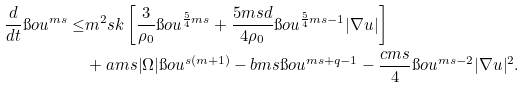<formula> <loc_0><loc_0><loc_500><loc_500>\frac { d } { d t } \i o u ^ { m s } \leq & m ^ { 2 } s k \left [ \frac { 3 } { \rho _ { 0 } } \i o u ^ { \frac { 5 } { 4 } m s } + \frac { 5 m s d } { 4 \rho _ { 0 } } \i o u ^ { \frac { 5 } { 4 } m s - 1 } | \nabla u | \right ] \\ & + a m s | \Omega | \i o u ^ { s ( m + 1 ) } - b m s \i o u ^ { m s + q - 1 } - \frac { c m s } { 4 } \i o u ^ { m s - 2 } | \nabla u | ^ { 2 } .</formula> 